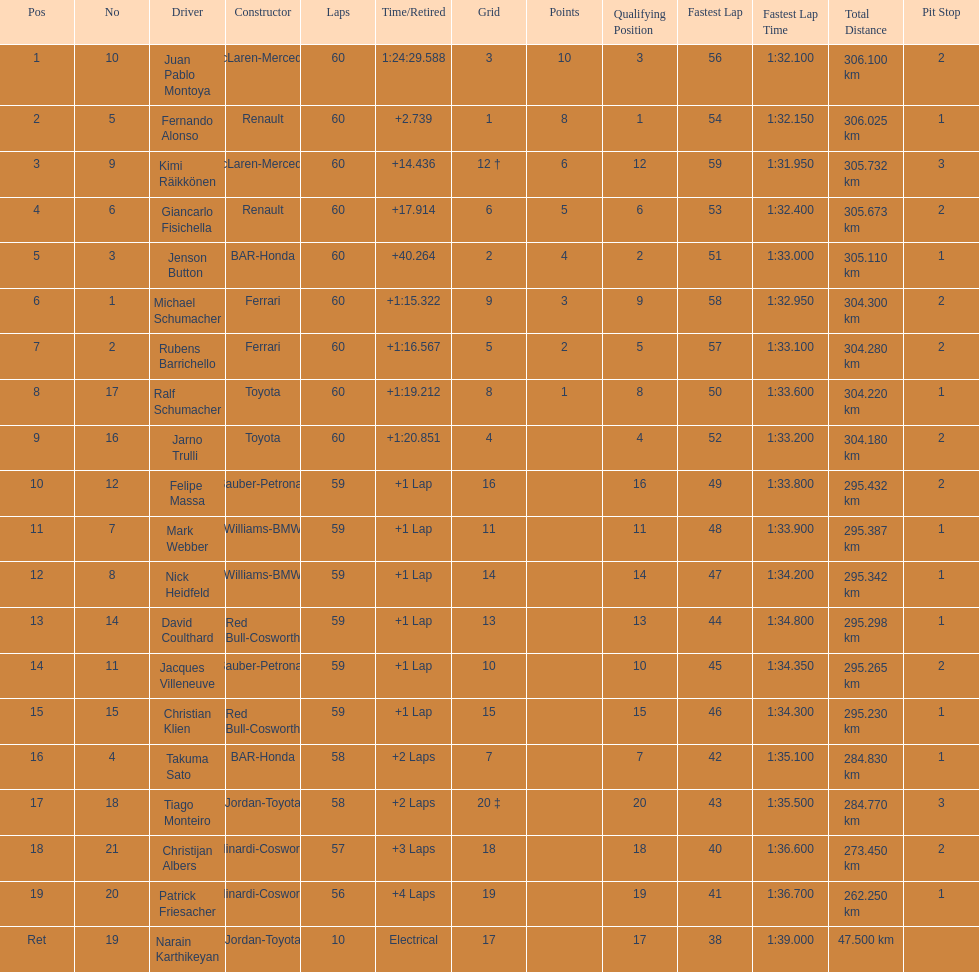What is the number of toyota's on the list? 4. 